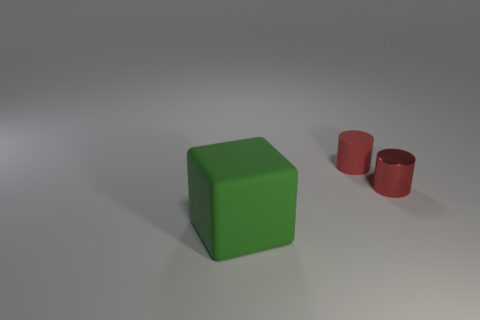Add 2 small purple matte objects. How many objects exist? 5 Subtract all cylinders. How many objects are left? 1 Subtract all small gray matte objects. Subtract all small metallic cylinders. How many objects are left? 2 Add 1 red shiny things. How many red shiny things are left? 2 Add 3 rubber cylinders. How many rubber cylinders exist? 4 Subtract 0 brown cubes. How many objects are left? 3 